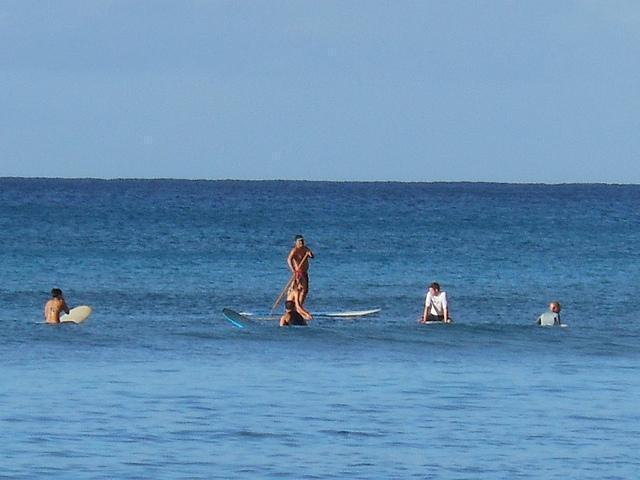What is the man who is standing doing?
Pick the correct solution from the four options below to address the question.
Options: Jumping, waving, rowing, eating. Rowing. 